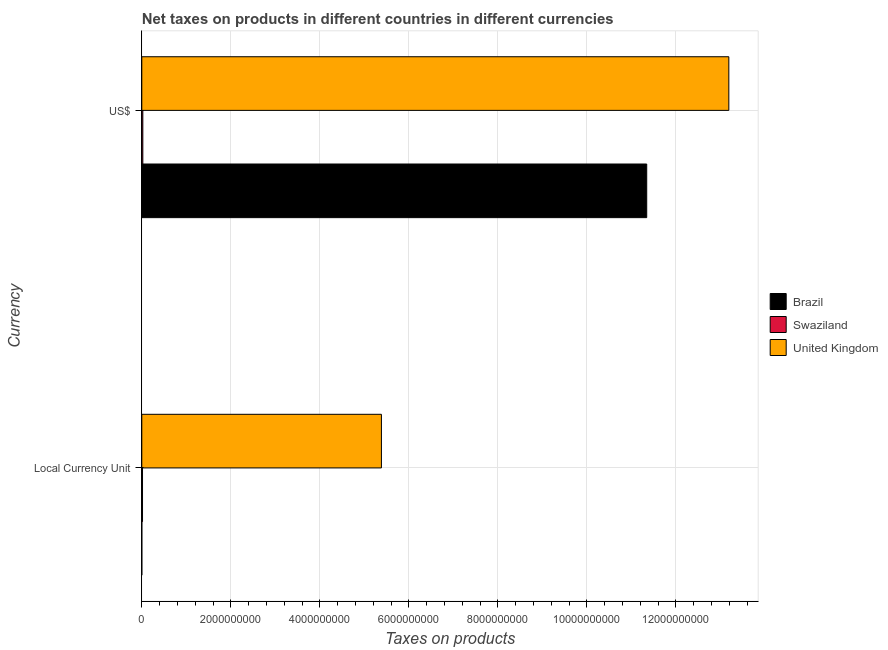Are the number of bars per tick equal to the number of legend labels?
Your response must be concise. Yes. Are the number of bars on each tick of the Y-axis equal?
Keep it short and to the point. Yes. How many bars are there on the 1st tick from the top?
Your answer should be compact. 3. How many bars are there on the 1st tick from the bottom?
Keep it short and to the point. 3. What is the label of the 2nd group of bars from the top?
Your response must be concise. Local Currency Unit. What is the net taxes in constant 2005 us$ in Swaziland?
Keep it short and to the point. 1.60e+07. Across all countries, what is the maximum net taxes in constant 2005 us$?
Make the answer very short. 5.38e+09. Across all countries, what is the minimum net taxes in constant 2005 us$?
Provide a short and direct response. 0.03. In which country was the net taxes in us$ minimum?
Provide a short and direct response. Swaziland. What is the total net taxes in us$ in the graph?
Your response must be concise. 2.46e+1. What is the difference between the net taxes in constant 2005 us$ in Swaziland and that in United Kingdom?
Keep it short and to the point. -5.37e+09. What is the difference between the net taxes in constant 2005 us$ in United Kingdom and the net taxes in us$ in Brazil?
Keep it short and to the point. -5.96e+09. What is the average net taxes in us$ per country?
Offer a terse response. 8.19e+09. What is the difference between the net taxes in us$ and net taxes in constant 2005 us$ in Brazil?
Keep it short and to the point. 1.13e+1. In how many countries, is the net taxes in constant 2005 us$ greater than 10800000000 units?
Make the answer very short. 0. What is the ratio of the net taxes in us$ in Swaziland to that in United Kingdom?
Ensure brevity in your answer.  0. In how many countries, is the net taxes in us$ greater than the average net taxes in us$ taken over all countries?
Your response must be concise. 2. What does the 2nd bar from the bottom in US$ represents?
Give a very brief answer. Swaziland. How many bars are there?
Provide a short and direct response. 6. What is the difference between two consecutive major ticks on the X-axis?
Your response must be concise. 2.00e+09. Does the graph contain grids?
Keep it short and to the point. Yes. How are the legend labels stacked?
Your response must be concise. Vertical. What is the title of the graph?
Your answer should be very brief. Net taxes on products in different countries in different currencies. Does "Hungary" appear as one of the legend labels in the graph?
Offer a very short reply. No. What is the label or title of the X-axis?
Offer a terse response. Taxes on products. What is the label or title of the Y-axis?
Give a very brief answer. Currency. What is the Taxes on products in Brazil in Local Currency Unit?
Provide a succinct answer. 0.03. What is the Taxes on products in Swaziland in Local Currency Unit?
Your answer should be compact. 1.60e+07. What is the Taxes on products in United Kingdom in Local Currency Unit?
Ensure brevity in your answer.  5.38e+09. What is the Taxes on products of Brazil in US$?
Your answer should be very brief. 1.13e+1. What is the Taxes on products in Swaziland in US$?
Provide a short and direct response. 2.31e+07. What is the Taxes on products in United Kingdom in US$?
Offer a terse response. 1.32e+1. Across all Currency, what is the maximum Taxes on products in Brazil?
Keep it short and to the point. 1.13e+1. Across all Currency, what is the maximum Taxes on products of Swaziland?
Offer a terse response. 2.31e+07. Across all Currency, what is the maximum Taxes on products in United Kingdom?
Provide a succinct answer. 1.32e+1. Across all Currency, what is the minimum Taxes on products in Brazil?
Your answer should be compact. 0.03. Across all Currency, what is the minimum Taxes on products in Swaziland?
Your answer should be compact. 1.60e+07. Across all Currency, what is the minimum Taxes on products in United Kingdom?
Your answer should be compact. 5.38e+09. What is the total Taxes on products of Brazil in the graph?
Ensure brevity in your answer.  1.13e+1. What is the total Taxes on products of Swaziland in the graph?
Make the answer very short. 3.91e+07. What is the total Taxes on products of United Kingdom in the graph?
Offer a very short reply. 1.86e+1. What is the difference between the Taxes on products in Brazil in Local Currency Unit and that in US$?
Your response must be concise. -1.13e+1. What is the difference between the Taxes on products in Swaziland in Local Currency Unit and that in US$?
Offer a terse response. -7.06e+06. What is the difference between the Taxes on products of United Kingdom in Local Currency Unit and that in US$?
Make the answer very short. -7.81e+09. What is the difference between the Taxes on products in Brazil in Local Currency Unit and the Taxes on products in Swaziland in US$?
Offer a terse response. -2.31e+07. What is the difference between the Taxes on products in Brazil in Local Currency Unit and the Taxes on products in United Kingdom in US$?
Your response must be concise. -1.32e+1. What is the difference between the Taxes on products in Swaziland in Local Currency Unit and the Taxes on products in United Kingdom in US$?
Make the answer very short. -1.32e+1. What is the average Taxes on products of Brazil per Currency?
Provide a short and direct response. 5.67e+09. What is the average Taxes on products of Swaziland per Currency?
Provide a short and direct response. 1.95e+07. What is the average Taxes on products of United Kingdom per Currency?
Provide a succinct answer. 9.29e+09. What is the difference between the Taxes on products of Brazil and Taxes on products of Swaziland in Local Currency Unit?
Provide a succinct answer. -1.60e+07. What is the difference between the Taxes on products of Brazil and Taxes on products of United Kingdom in Local Currency Unit?
Provide a succinct answer. -5.38e+09. What is the difference between the Taxes on products in Swaziland and Taxes on products in United Kingdom in Local Currency Unit?
Your answer should be very brief. -5.37e+09. What is the difference between the Taxes on products in Brazil and Taxes on products in Swaziland in US$?
Your answer should be compact. 1.13e+1. What is the difference between the Taxes on products of Brazil and Taxes on products of United Kingdom in US$?
Your answer should be very brief. -1.85e+09. What is the difference between the Taxes on products in Swaziland and Taxes on products in United Kingdom in US$?
Keep it short and to the point. -1.32e+1. What is the ratio of the Taxes on products in Brazil in Local Currency Unit to that in US$?
Give a very brief answer. 0. What is the ratio of the Taxes on products in Swaziland in Local Currency Unit to that in US$?
Keep it short and to the point. 0.69. What is the ratio of the Taxes on products of United Kingdom in Local Currency Unit to that in US$?
Give a very brief answer. 0.41. What is the difference between the highest and the second highest Taxes on products in Brazil?
Provide a short and direct response. 1.13e+1. What is the difference between the highest and the second highest Taxes on products in Swaziland?
Your response must be concise. 7.06e+06. What is the difference between the highest and the second highest Taxes on products in United Kingdom?
Offer a very short reply. 7.81e+09. What is the difference between the highest and the lowest Taxes on products in Brazil?
Offer a terse response. 1.13e+1. What is the difference between the highest and the lowest Taxes on products in Swaziland?
Provide a succinct answer. 7.06e+06. What is the difference between the highest and the lowest Taxes on products of United Kingdom?
Keep it short and to the point. 7.81e+09. 